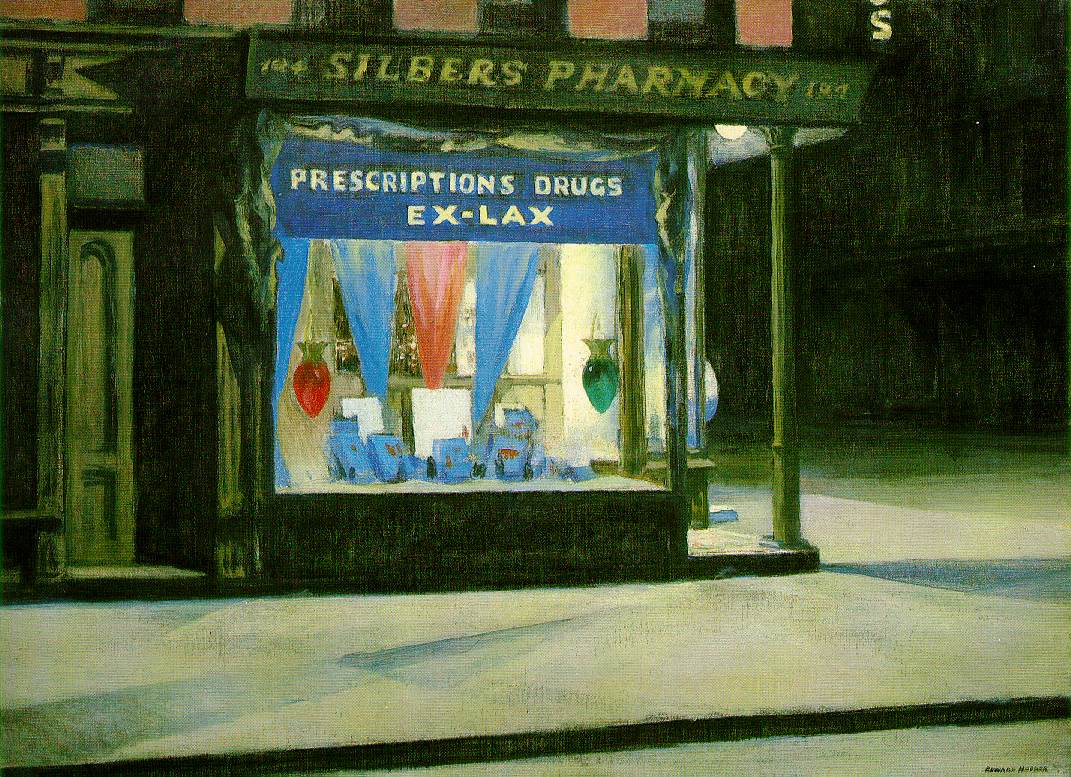Could you discuss the emotional impact or mood conveyed by this painting, and how does the artist achieve it? The painting emanates a mood of solitude and introspection, profoundly impacted by its use of lighting and color. The artist achieves this through the contrast between the dark, almost brooding street and the brightly lit, colorful window display. The absence of people also plays a critical role, emphasizing silence and the stillness of the night. The detailed and realistic portrayal ensures that viewers are drawn into this quiet, solitary moment, reflecting perhaps on the unseen lives of those who pass by this pharmacy daily. 